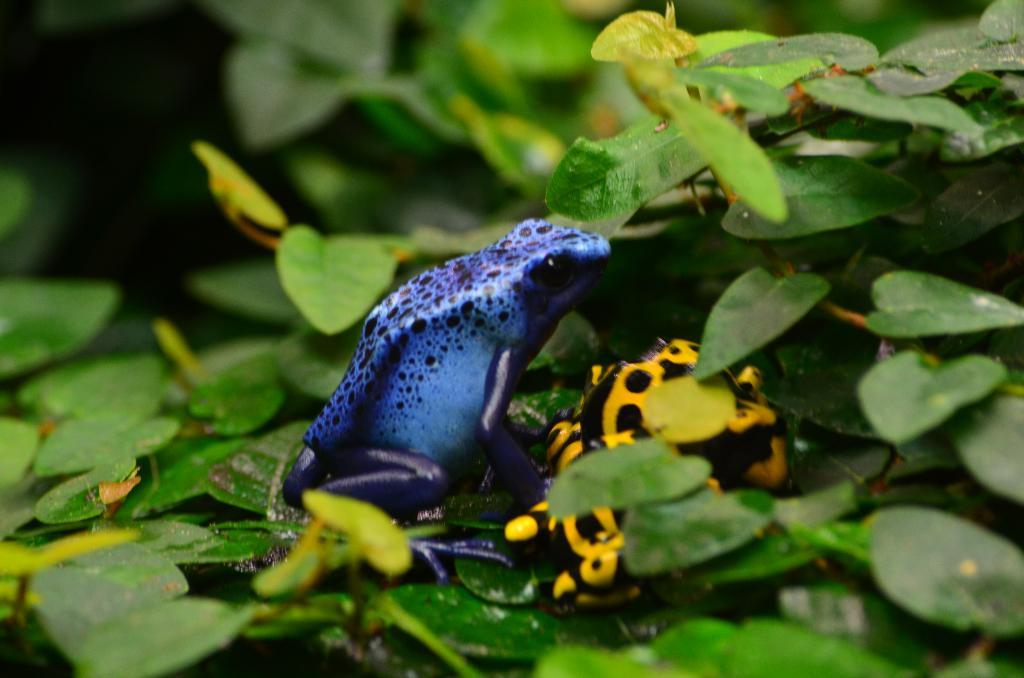What animals are present in the image? There are two frogs in the image. Where are the frogs located in the image? The frogs are between leaves. Can you describe the background of the image? The background of the image is blurry. What type of dolls can be seen in the image? There are no dolls present in the image; it features two frogs between leaves. What kind of haircut can be seen on the frogs in the image? Frogs do not have hair, so there is no haircut visible in the image. 